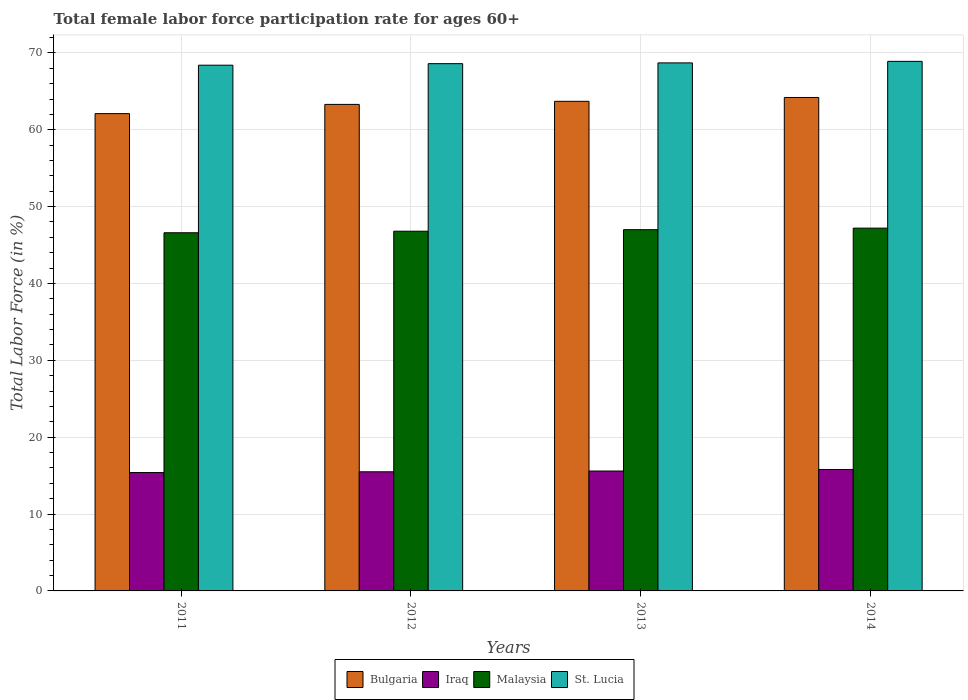How many different coloured bars are there?
Offer a very short reply. 4. How many groups of bars are there?
Ensure brevity in your answer.  4. Are the number of bars per tick equal to the number of legend labels?
Offer a terse response. Yes. How many bars are there on the 2nd tick from the right?
Your response must be concise. 4. What is the label of the 2nd group of bars from the left?
Give a very brief answer. 2012. What is the female labor force participation rate in Iraq in 2011?
Ensure brevity in your answer.  15.4. Across all years, what is the maximum female labor force participation rate in Malaysia?
Give a very brief answer. 47.2. Across all years, what is the minimum female labor force participation rate in St. Lucia?
Your answer should be compact. 68.4. What is the total female labor force participation rate in Malaysia in the graph?
Offer a very short reply. 187.6. What is the difference between the female labor force participation rate in Iraq in 2012 and that in 2013?
Provide a succinct answer. -0.1. What is the difference between the female labor force participation rate in Iraq in 2011 and the female labor force participation rate in St. Lucia in 2013?
Offer a terse response. -53.3. What is the average female labor force participation rate in Bulgaria per year?
Ensure brevity in your answer.  63.32. In the year 2012, what is the difference between the female labor force participation rate in Malaysia and female labor force participation rate in Bulgaria?
Keep it short and to the point. -16.5. What is the ratio of the female labor force participation rate in Malaysia in 2011 to that in 2013?
Provide a succinct answer. 0.99. Is the difference between the female labor force participation rate in Malaysia in 2013 and 2014 greater than the difference between the female labor force participation rate in Bulgaria in 2013 and 2014?
Offer a terse response. Yes. What is the difference between the highest and the second highest female labor force participation rate in Bulgaria?
Make the answer very short. 0.5. What is the difference between the highest and the lowest female labor force participation rate in Iraq?
Keep it short and to the point. 0.4. In how many years, is the female labor force participation rate in Malaysia greater than the average female labor force participation rate in Malaysia taken over all years?
Keep it short and to the point. 2. Is it the case that in every year, the sum of the female labor force participation rate in Malaysia and female labor force participation rate in St. Lucia is greater than the sum of female labor force participation rate in Bulgaria and female labor force participation rate in Iraq?
Provide a succinct answer. No. What does the 4th bar from the left in 2011 represents?
Your answer should be compact. St. Lucia. What does the 3rd bar from the right in 2014 represents?
Keep it short and to the point. Iraq. Is it the case that in every year, the sum of the female labor force participation rate in Malaysia and female labor force participation rate in Iraq is greater than the female labor force participation rate in St. Lucia?
Offer a terse response. No. How many bars are there?
Make the answer very short. 16. Are all the bars in the graph horizontal?
Ensure brevity in your answer.  No. How many years are there in the graph?
Ensure brevity in your answer.  4. Are the values on the major ticks of Y-axis written in scientific E-notation?
Your answer should be compact. No. Does the graph contain any zero values?
Your answer should be very brief. No. Where does the legend appear in the graph?
Keep it short and to the point. Bottom center. How are the legend labels stacked?
Give a very brief answer. Horizontal. What is the title of the graph?
Your answer should be very brief. Total female labor force participation rate for ages 60+. Does "Georgia" appear as one of the legend labels in the graph?
Offer a very short reply. No. What is the Total Labor Force (in %) in Bulgaria in 2011?
Give a very brief answer. 62.1. What is the Total Labor Force (in %) of Iraq in 2011?
Offer a terse response. 15.4. What is the Total Labor Force (in %) of Malaysia in 2011?
Ensure brevity in your answer.  46.6. What is the Total Labor Force (in %) in St. Lucia in 2011?
Make the answer very short. 68.4. What is the Total Labor Force (in %) of Bulgaria in 2012?
Keep it short and to the point. 63.3. What is the Total Labor Force (in %) of Iraq in 2012?
Give a very brief answer. 15.5. What is the Total Labor Force (in %) in Malaysia in 2012?
Ensure brevity in your answer.  46.8. What is the Total Labor Force (in %) of St. Lucia in 2012?
Keep it short and to the point. 68.6. What is the Total Labor Force (in %) in Bulgaria in 2013?
Make the answer very short. 63.7. What is the Total Labor Force (in %) in Iraq in 2013?
Provide a succinct answer. 15.6. What is the Total Labor Force (in %) of Malaysia in 2013?
Make the answer very short. 47. What is the Total Labor Force (in %) of St. Lucia in 2013?
Keep it short and to the point. 68.7. What is the Total Labor Force (in %) in Bulgaria in 2014?
Provide a short and direct response. 64.2. What is the Total Labor Force (in %) in Iraq in 2014?
Your answer should be compact. 15.8. What is the Total Labor Force (in %) of Malaysia in 2014?
Your answer should be compact. 47.2. What is the Total Labor Force (in %) of St. Lucia in 2014?
Keep it short and to the point. 68.9. Across all years, what is the maximum Total Labor Force (in %) of Bulgaria?
Your answer should be very brief. 64.2. Across all years, what is the maximum Total Labor Force (in %) in Iraq?
Offer a terse response. 15.8. Across all years, what is the maximum Total Labor Force (in %) in Malaysia?
Your answer should be compact. 47.2. Across all years, what is the maximum Total Labor Force (in %) in St. Lucia?
Ensure brevity in your answer.  68.9. Across all years, what is the minimum Total Labor Force (in %) in Bulgaria?
Your answer should be very brief. 62.1. Across all years, what is the minimum Total Labor Force (in %) of Iraq?
Provide a short and direct response. 15.4. Across all years, what is the minimum Total Labor Force (in %) in Malaysia?
Offer a terse response. 46.6. Across all years, what is the minimum Total Labor Force (in %) of St. Lucia?
Keep it short and to the point. 68.4. What is the total Total Labor Force (in %) in Bulgaria in the graph?
Your answer should be compact. 253.3. What is the total Total Labor Force (in %) in Iraq in the graph?
Provide a succinct answer. 62.3. What is the total Total Labor Force (in %) of Malaysia in the graph?
Give a very brief answer. 187.6. What is the total Total Labor Force (in %) in St. Lucia in the graph?
Provide a short and direct response. 274.6. What is the difference between the Total Labor Force (in %) of Bulgaria in 2011 and that in 2012?
Your answer should be very brief. -1.2. What is the difference between the Total Labor Force (in %) in Iraq in 2011 and that in 2012?
Offer a very short reply. -0.1. What is the difference between the Total Labor Force (in %) of Malaysia in 2011 and that in 2012?
Ensure brevity in your answer.  -0.2. What is the difference between the Total Labor Force (in %) in St. Lucia in 2011 and that in 2012?
Provide a short and direct response. -0.2. What is the difference between the Total Labor Force (in %) of Iraq in 2011 and that in 2013?
Give a very brief answer. -0.2. What is the difference between the Total Labor Force (in %) of Malaysia in 2011 and that in 2013?
Keep it short and to the point. -0.4. What is the difference between the Total Labor Force (in %) of Malaysia in 2011 and that in 2014?
Provide a short and direct response. -0.6. What is the difference between the Total Labor Force (in %) of St. Lucia in 2011 and that in 2014?
Your response must be concise. -0.5. What is the difference between the Total Labor Force (in %) in Bulgaria in 2012 and that in 2013?
Give a very brief answer. -0.4. What is the difference between the Total Labor Force (in %) of St. Lucia in 2012 and that in 2013?
Give a very brief answer. -0.1. What is the difference between the Total Labor Force (in %) of Malaysia in 2012 and that in 2014?
Ensure brevity in your answer.  -0.4. What is the difference between the Total Labor Force (in %) in Bulgaria in 2013 and that in 2014?
Your response must be concise. -0.5. What is the difference between the Total Labor Force (in %) of Iraq in 2013 and that in 2014?
Your response must be concise. -0.2. What is the difference between the Total Labor Force (in %) in Malaysia in 2013 and that in 2014?
Provide a succinct answer. -0.2. What is the difference between the Total Labor Force (in %) of Bulgaria in 2011 and the Total Labor Force (in %) of Iraq in 2012?
Offer a very short reply. 46.6. What is the difference between the Total Labor Force (in %) in Bulgaria in 2011 and the Total Labor Force (in %) in St. Lucia in 2012?
Offer a very short reply. -6.5. What is the difference between the Total Labor Force (in %) in Iraq in 2011 and the Total Labor Force (in %) in Malaysia in 2012?
Keep it short and to the point. -31.4. What is the difference between the Total Labor Force (in %) in Iraq in 2011 and the Total Labor Force (in %) in St. Lucia in 2012?
Keep it short and to the point. -53.2. What is the difference between the Total Labor Force (in %) of Bulgaria in 2011 and the Total Labor Force (in %) of Iraq in 2013?
Offer a terse response. 46.5. What is the difference between the Total Labor Force (in %) in Bulgaria in 2011 and the Total Labor Force (in %) in St. Lucia in 2013?
Provide a succinct answer. -6.6. What is the difference between the Total Labor Force (in %) in Iraq in 2011 and the Total Labor Force (in %) in Malaysia in 2013?
Provide a short and direct response. -31.6. What is the difference between the Total Labor Force (in %) in Iraq in 2011 and the Total Labor Force (in %) in St. Lucia in 2013?
Keep it short and to the point. -53.3. What is the difference between the Total Labor Force (in %) of Malaysia in 2011 and the Total Labor Force (in %) of St. Lucia in 2013?
Offer a terse response. -22.1. What is the difference between the Total Labor Force (in %) in Bulgaria in 2011 and the Total Labor Force (in %) in Iraq in 2014?
Your answer should be very brief. 46.3. What is the difference between the Total Labor Force (in %) in Bulgaria in 2011 and the Total Labor Force (in %) in Malaysia in 2014?
Offer a very short reply. 14.9. What is the difference between the Total Labor Force (in %) of Iraq in 2011 and the Total Labor Force (in %) of Malaysia in 2014?
Your response must be concise. -31.8. What is the difference between the Total Labor Force (in %) in Iraq in 2011 and the Total Labor Force (in %) in St. Lucia in 2014?
Give a very brief answer. -53.5. What is the difference between the Total Labor Force (in %) of Malaysia in 2011 and the Total Labor Force (in %) of St. Lucia in 2014?
Your answer should be very brief. -22.3. What is the difference between the Total Labor Force (in %) of Bulgaria in 2012 and the Total Labor Force (in %) of Iraq in 2013?
Provide a succinct answer. 47.7. What is the difference between the Total Labor Force (in %) in Bulgaria in 2012 and the Total Labor Force (in %) in Malaysia in 2013?
Your answer should be very brief. 16.3. What is the difference between the Total Labor Force (in %) in Iraq in 2012 and the Total Labor Force (in %) in Malaysia in 2013?
Provide a succinct answer. -31.5. What is the difference between the Total Labor Force (in %) of Iraq in 2012 and the Total Labor Force (in %) of St. Lucia in 2013?
Your answer should be compact. -53.2. What is the difference between the Total Labor Force (in %) in Malaysia in 2012 and the Total Labor Force (in %) in St. Lucia in 2013?
Provide a succinct answer. -21.9. What is the difference between the Total Labor Force (in %) of Bulgaria in 2012 and the Total Labor Force (in %) of Iraq in 2014?
Provide a succinct answer. 47.5. What is the difference between the Total Labor Force (in %) of Bulgaria in 2012 and the Total Labor Force (in %) of Malaysia in 2014?
Your answer should be very brief. 16.1. What is the difference between the Total Labor Force (in %) of Bulgaria in 2012 and the Total Labor Force (in %) of St. Lucia in 2014?
Offer a very short reply. -5.6. What is the difference between the Total Labor Force (in %) in Iraq in 2012 and the Total Labor Force (in %) in Malaysia in 2014?
Your response must be concise. -31.7. What is the difference between the Total Labor Force (in %) in Iraq in 2012 and the Total Labor Force (in %) in St. Lucia in 2014?
Offer a very short reply. -53.4. What is the difference between the Total Labor Force (in %) in Malaysia in 2012 and the Total Labor Force (in %) in St. Lucia in 2014?
Keep it short and to the point. -22.1. What is the difference between the Total Labor Force (in %) of Bulgaria in 2013 and the Total Labor Force (in %) of Iraq in 2014?
Keep it short and to the point. 47.9. What is the difference between the Total Labor Force (in %) of Bulgaria in 2013 and the Total Labor Force (in %) of St. Lucia in 2014?
Give a very brief answer. -5.2. What is the difference between the Total Labor Force (in %) of Iraq in 2013 and the Total Labor Force (in %) of Malaysia in 2014?
Offer a terse response. -31.6. What is the difference between the Total Labor Force (in %) of Iraq in 2013 and the Total Labor Force (in %) of St. Lucia in 2014?
Give a very brief answer. -53.3. What is the difference between the Total Labor Force (in %) of Malaysia in 2013 and the Total Labor Force (in %) of St. Lucia in 2014?
Your answer should be compact. -21.9. What is the average Total Labor Force (in %) in Bulgaria per year?
Ensure brevity in your answer.  63.33. What is the average Total Labor Force (in %) of Iraq per year?
Provide a short and direct response. 15.57. What is the average Total Labor Force (in %) of Malaysia per year?
Offer a terse response. 46.9. What is the average Total Labor Force (in %) of St. Lucia per year?
Make the answer very short. 68.65. In the year 2011, what is the difference between the Total Labor Force (in %) in Bulgaria and Total Labor Force (in %) in Iraq?
Provide a succinct answer. 46.7. In the year 2011, what is the difference between the Total Labor Force (in %) in Bulgaria and Total Labor Force (in %) in Malaysia?
Provide a succinct answer. 15.5. In the year 2011, what is the difference between the Total Labor Force (in %) of Bulgaria and Total Labor Force (in %) of St. Lucia?
Keep it short and to the point. -6.3. In the year 2011, what is the difference between the Total Labor Force (in %) in Iraq and Total Labor Force (in %) in Malaysia?
Keep it short and to the point. -31.2. In the year 2011, what is the difference between the Total Labor Force (in %) in Iraq and Total Labor Force (in %) in St. Lucia?
Offer a terse response. -53. In the year 2011, what is the difference between the Total Labor Force (in %) in Malaysia and Total Labor Force (in %) in St. Lucia?
Your answer should be compact. -21.8. In the year 2012, what is the difference between the Total Labor Force (in %) in Bulgaria and Total Labor Force (in %) in Iraq?
Provide a short and direct response. 47.8. In the year 2012, what is the difference between the Total Labor Force (in %) in Iraq and Total Labor Force (in %) in Malaysia?
Provide a succinct answer. -31.3. In the year 2012, what is the difference between the Total Labor Force (in %) in Iraq and Total Labor Force (in %) in St. Lucia?
Give a very brief answer. -53.1. In the year 2012, what is the difference between the Total Labor Force (in %) of Malaysia and Total Labor Force (in %) of St. Lucia?
Your answer should be compact. -21.8. In the year 2013, what is the difference between the Total Labor Force (in %) in Bulgaria and Total Labor Force (in %) in Iraq?
Ensure brevity in your answer.  48.1. In the year 2013, what is the difference between the Total Labor Force (in %) of Bulgaria and Total Labor Force (in %) of Malaysia?
Offer a very short reply. 16.7. In the year 2013, what is the difference between the Total Labor Force (in %) in Bulgaria and Total Labor Force (in %) in St. Lucia?
Offer a very short reply. -5. In the year 2013, what is the difference between the Total Labor Force (in %) in Iraq and Total Labor Force (in %) in Malaysia?
Make the answer very short. -31.4. In the year 2013, what is the difference between the Total Labor Force (in %) of Iraq and Total Labor Force (in %) of St. Lucia?
Make the answer very short. -53.1. In the year 2013, what is the difference between the Total Labor Force (in %) of Malaysia and Total Labor Force (in %) of St. Lucia?
Offer a very short reply. -21.7. In the year 2014, what is the difference between the Total Labor Force (in %) of Bulgaria and Total Labor Force (in %) of Iraq?
Keep it short and to the point. 48.4. In the year 2014, what is the difference between the Total Labor Force (in %) of Bulgaria and Total Labor Force (in %) of Malaysia?
Make the answer very short. 17. In the year 2014, what is the difference between the Total Labor Force (in %) in Bulgaria and Total Labor Force (in %) in St. Lucia?
Your answer should be very brief. -4.7. In the year 2014, what is the difference between the Total Labor Force (in %) of Iraq and Total Labor Force (in %) of Malaysia?
Keep it short and to the point. -31.4. In the year 2014, what is the difference between the Total Labor Force (in %) in Iraq and Total Labor Force (in %) in St. Lucia?
Your answer should be compact. -53.1. In the year 2014, what is the difference between the Total Labor Force (in %) in Malaysia and Total Labor Force (in %) in St. Lucia?
Provide a short and direct response. -21.7. What is the ratio of the Total Labor Force (in %) of Bulgaria in 2011 to that in 2012?
Ensure brevity in your answer.  0.98. What is the ratio of the Total Labor Force (in %) of Iraq in 2011 to that in 2012?
Offer a very short reply. 0.99. What is the ratio of the Total Labor Force (in %) of Malaysia in 2011 to that in 2012?
Provide a short and direct response. 1. What is the ratio of the Total Labor Force (in %) of Bulgaria in 2011 to that in 2013?
Provide a succinct answer. 0.97. What is the ratio of the Total Labor Force (in %) of Iraq in 2011 to that in 2013?
Your answer should be compact. 0.99. What is the ratio of the Total Labor Force (in %) in St. Lucia in 2011 to that in 2013?
Your response must be concise. 1. What is the ratio of the Total Labor Force (in %) of Bulgaria in 2011 to that in 2014?
Your answer should be compact. 0.97. What is the ratio of the Total Labor Force (in %) of Iraq in 2011 to that in 2014?
Your answer should be compact. 0.97. What is the ratio of the Total Labor Force (in %) in Malaysia in 2011 to that in 2014?
Provide a short and direct response. 0.99. What is the ratio of the Total Labor Force (in %) in St. Lucia in 2011 to that in 2014?
Your response must be concise. 0.99. What is the ratio of the Total Labor Force (in %) in St. Lucia in 2012 to that in 2013?
Ensure brevity in your answer.  1. What is the ratio of the Total Labor Force (in %) of Malaysia in 2012 to that in 2014?
Your answer should be compact. 0.99. What is the ratio of the Total Labor Force (in %) of St. Lucia in 2012 to that in 2014?
Your response must be concise. 1. What is the ratio of the Total Labor Force (in %) of Iraq in 2013 to that in 2014?
Make the answer very short. 0.99. What is the difference between the highest and the second highest Total Labor Force (in %) of Bulgaria?
Your answer should be compact. 0.5. What is the difference between the highest and the lowest Total Labor Force (in %) of Bulgaria?
Offer a terse response. 2.1. What is the difference between the highest and the lowest Total Labor Force (in %) of Iraq?
Make the answer very short. 0.4. What is the difference between the highest and the lowest Total Labor Force (in %) of St. Lucia?
Give a very brief answer. 0.5. 